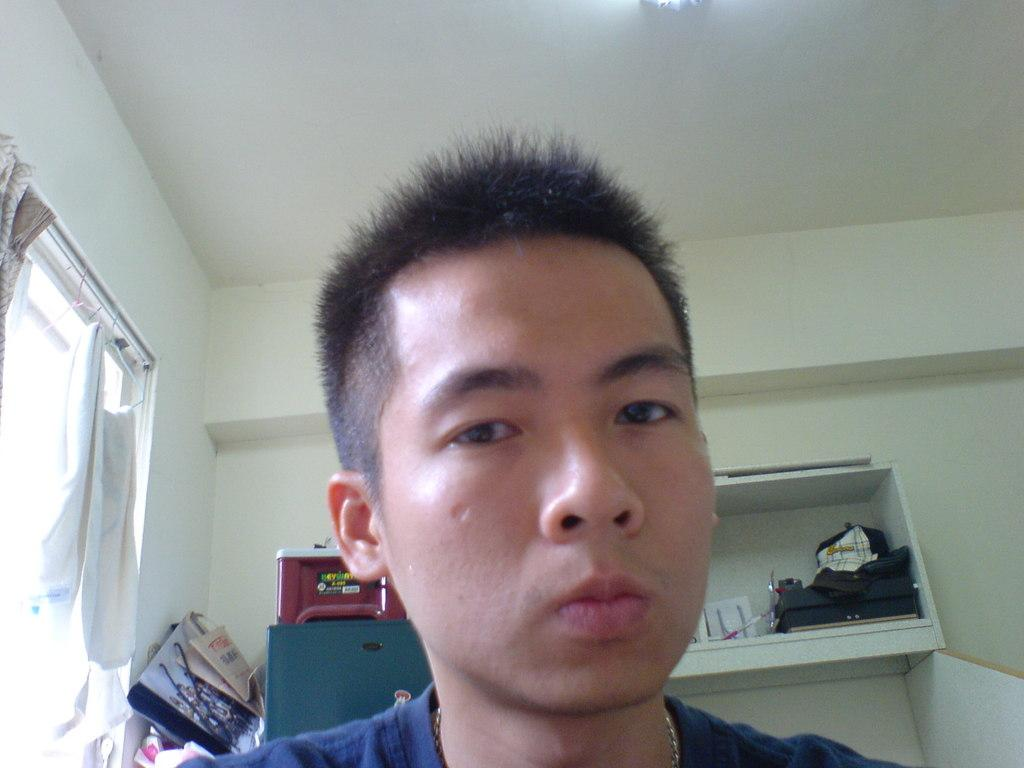Who is present in the image? There is a man in the image. What is the man wearing? The man is wearing a blue t-shirt. What type of furniture is visible in the image? There is a shelf in the image. What can be seen at the back of the image? There are other objects visible at the back. What architectural feature is present in the image? There is a window in the image. What type of window treatment is present? There are curtains associated withs associated with the window. What type of structure is visible in the image? There are walls visible in the image. How many horses are visible in the image? There are no horses present in the image. What type of judgment is the judge making in the image? There is no judge present in the image, so it is not possible to determine any judgments being made. 